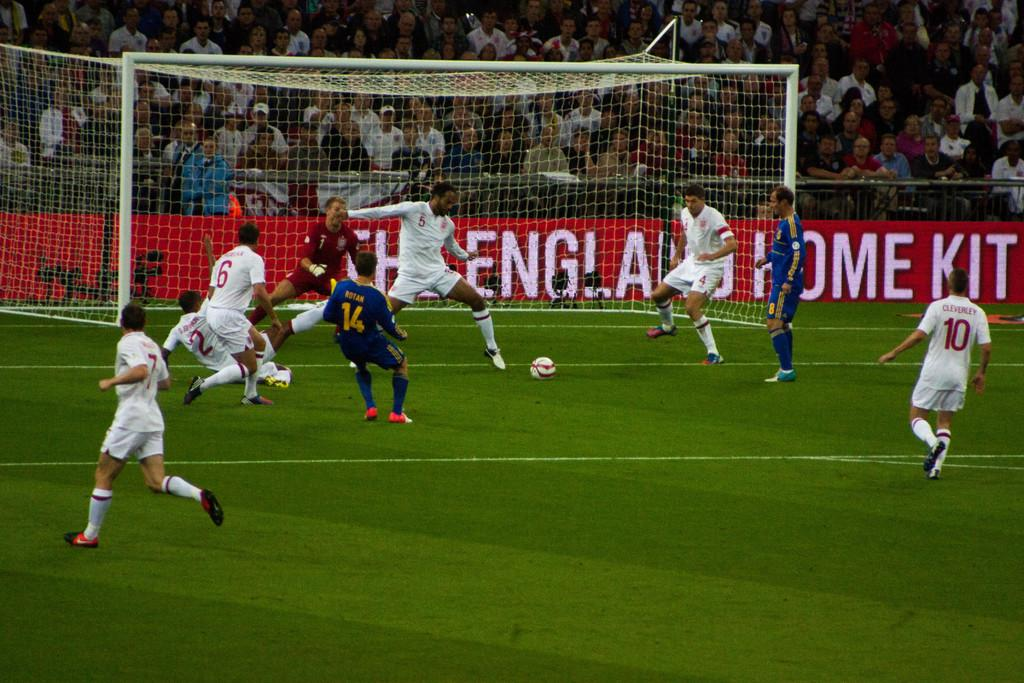<image>
Create a compact narrative representing the image presented. Number 5 is trying to prevent the blue team from scoring. 